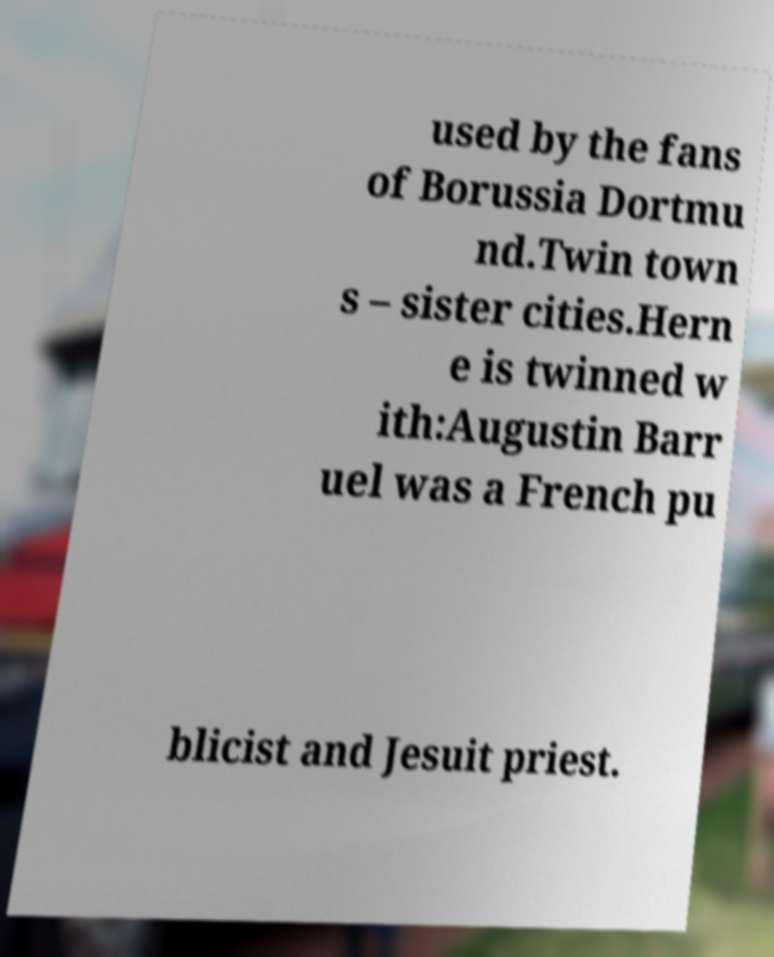Please read and relay the text visible in this image. What does it say? used by the fans of Borussia Dortmu nd.Twin town s – sister cities.Hern e is twinned w ith:Augustin Barr uel was a French pu blicist and Jesuit priest. 